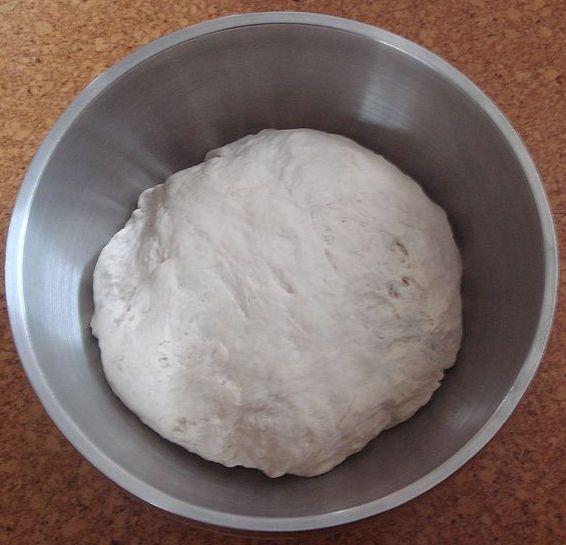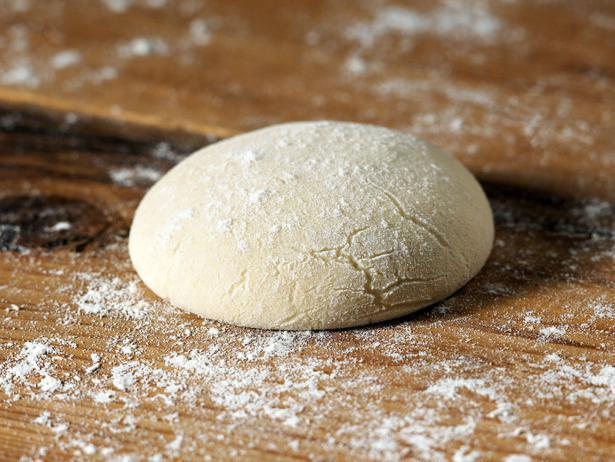The first image is the image on the left, the second image is the image on the right. Assess this claim about the two images: "At least one image has a large ball of dough in a bowl-like container, and not directly on a flat surface.". Correct or not? Answer yes or no. Yes. The first image is the image on the left, the second image is the image on the right. Considering the images on both sides, is "Each image contains one rounded mound of bread dough, and at least one of the depicted dough mounds is in a metal container." valid? Answer yes or no. Yes. 